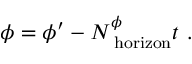<formula> <loc_0><loc_0><loc_500><loc_500>\phi = \phi ^ { \prime } - N _ { h o r i z o n } ^ { \phi } t \ .</formula> 